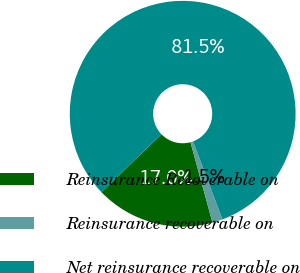<chart> <loc_0><loc_0><loc_500><loc_500><pie_chart><fcel>Reinsurance Recoverable on<fcel>Reinsurance recoverable on<fcel>Net reinsurance recoverable on<nl><fcel>17.04%<fcel>1.48%<fcel>81.48%<nl></chart> 